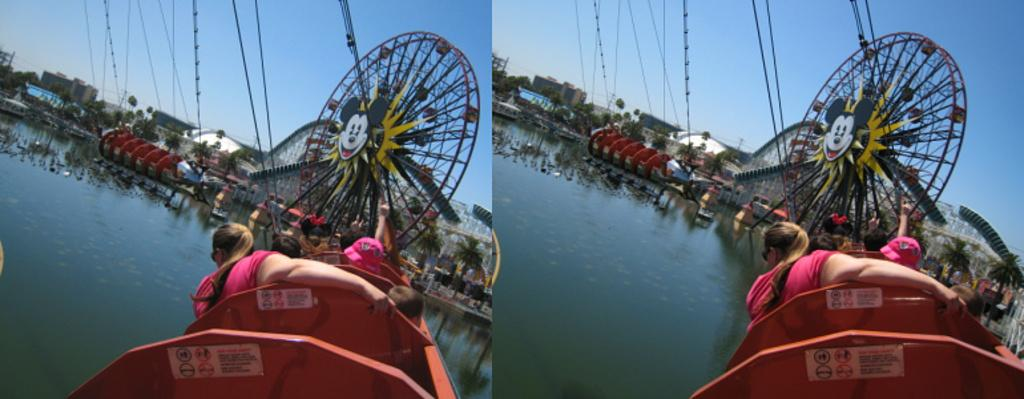What is the person in the image doing with the camera? The person is taking a picture of a building. Can you describe the person's position in the image? The person is holding a camera and standing. What is the main subject of the image? The main subject of the image is a person taking a picture of a building. What type of ear is visible on the person in the image? There is no ear visible on the person in the image, as the focus is on the person holding a camera and taking a picture of a building. --- What is the person in the image doing while sitting on the chair? The person is reading a book. Can you describe the person's position in the image? The person is sitting on a chair. What is the main subject of the image? The main subject of the image is a person sitting on a chair and reading a book. Reasoning: Let's think step by step in order to produce the conversation. We start by identifying the main subject in the image, which is the person sitting on a chair and reading a book. Then, we expand the conversation to include the person's actions and position in the image. Each question is designed to elicit a specific detail about the image that is known from the provided facts. Absurd Question/Answer: What type of stage can be seen in the image? There is no stage present in the image, as the focus is on a person sitting on a chair and reading a book. --- What are the people in the image doing near the car? The people are standing near a car. Can you describe the people's position in the image? The people are standing near a car. What is the main subject of the image? The main subject of the image is a group of people standing near a car. Reasoning: Let's think step by step in order to produce the conversation. We start by identifying the main subject in the image, which is the group of people standing near a car. Then, we expand the conversation to include the people's actions and position in the image. Each question is designed to elicit a specific detail about the image that is known from the provided facts. Absurd Question/Answer: What type of cakes are being served at the event in the image? There is no event or cakes present in the image, as the focus is on a group of people standing near a car. --- What is the person in the image doing while riding a bicycle? The person is riding a bicycle. Can you describe the person's position in the image? The person is riding a bicycle on the road. What is the main subject of the image? The main subject of the image is a person riding a bicycle on the road. Reasoning: Let's think step by step in order to produce the conversation. We start by identifying 